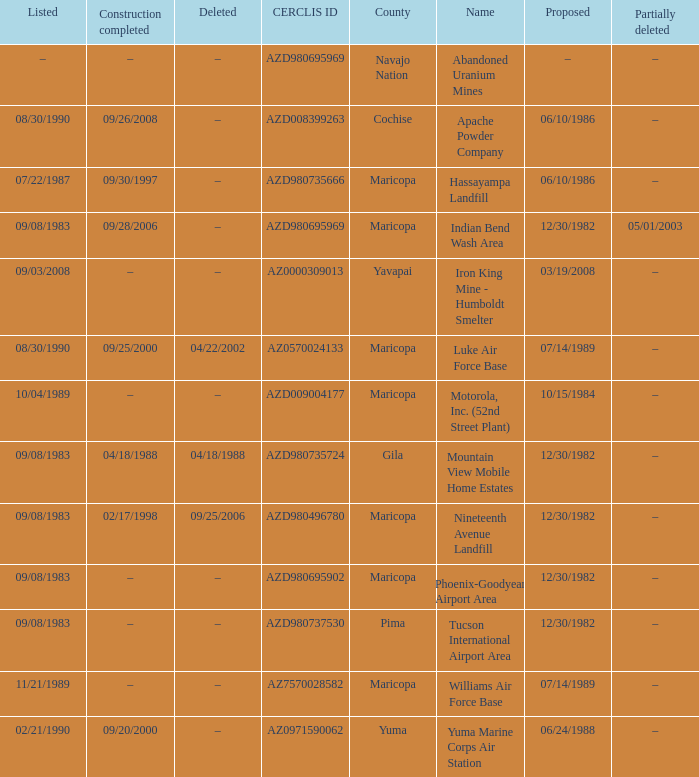What is the cerclis id when the site was proposed on 12/30/1982 and was partially deleted on 05/01/2003? AZD980695969. 